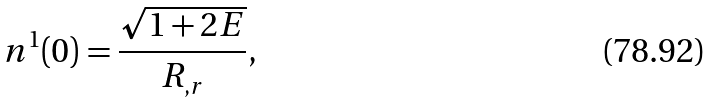Convert formula to latex. <formula><loc_0><loc_0><loc_500><loc_500>n ^ { 1 } ( 0 ) = \frac { \sqrt { 1 + 2 E } } { R _ { , r } } ,</formula> 